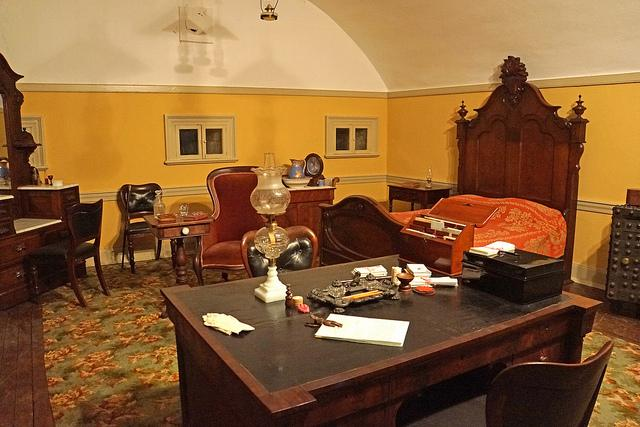What kind of fuel does the lamp use?

Choices:
A) manure
B) fossil
C) wood
D) solar fossil 